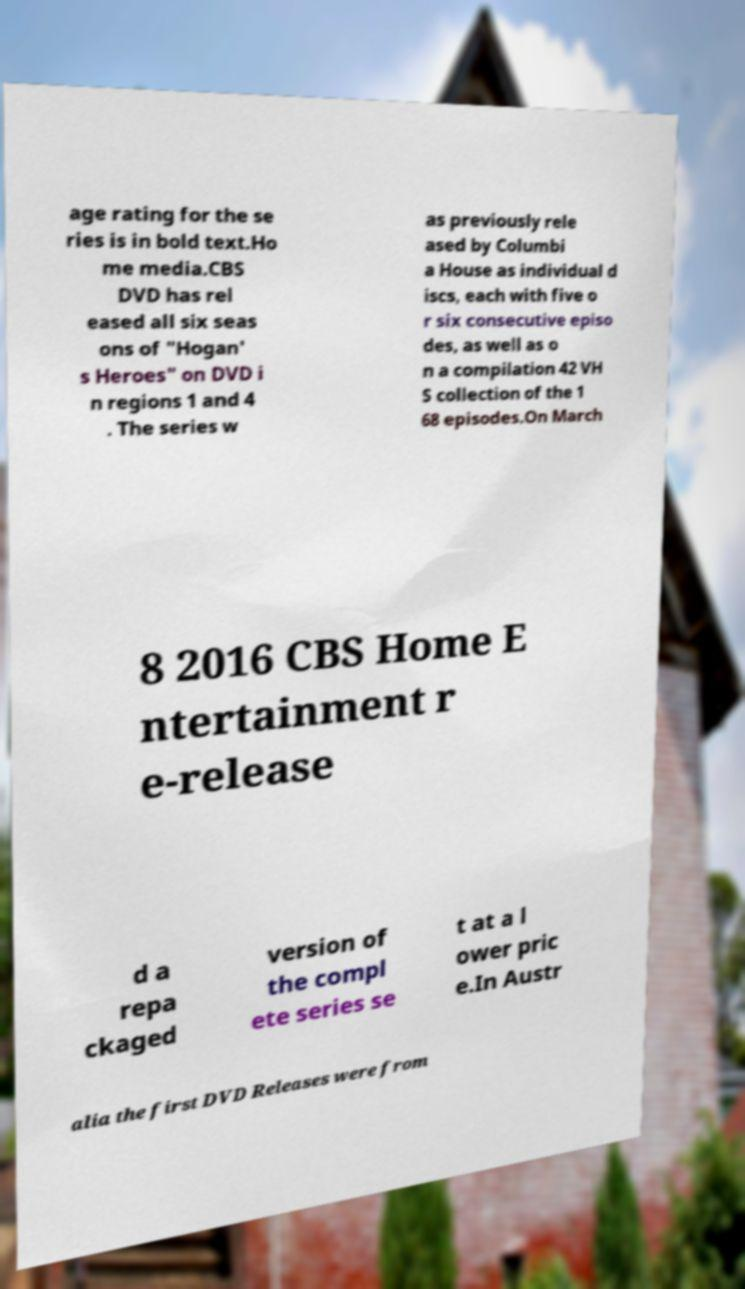For documentation purposes, I need the text within this image transcribed. Could you provide that? age rating for the se ries is in bold text.Ho me media.CBS DVD has rel eased all six seas ons of "Hogan' s Heroes" on DVD i n regions 1 and 4 . The series w as previously rele ased by Columbi a House as individual d iscs, each with five o r six consecutive episo des, as well as o n a compilation 42 VH S collection of the 1 68 episodes.On March 8 2016 CBS Home E ntertainment r e-release d a repa ckaged version of the compl ete series se t at a l ower pric e.In Austr alia the first DVD Releases were from 